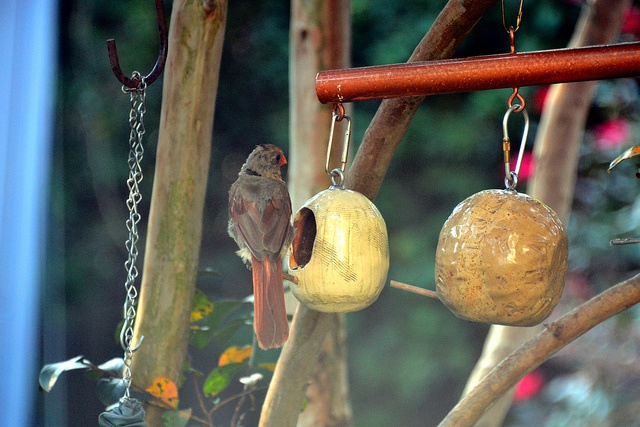Describe the objects in this image and their specific colors. I can see a bird in gray and darkgray tones in this image. 